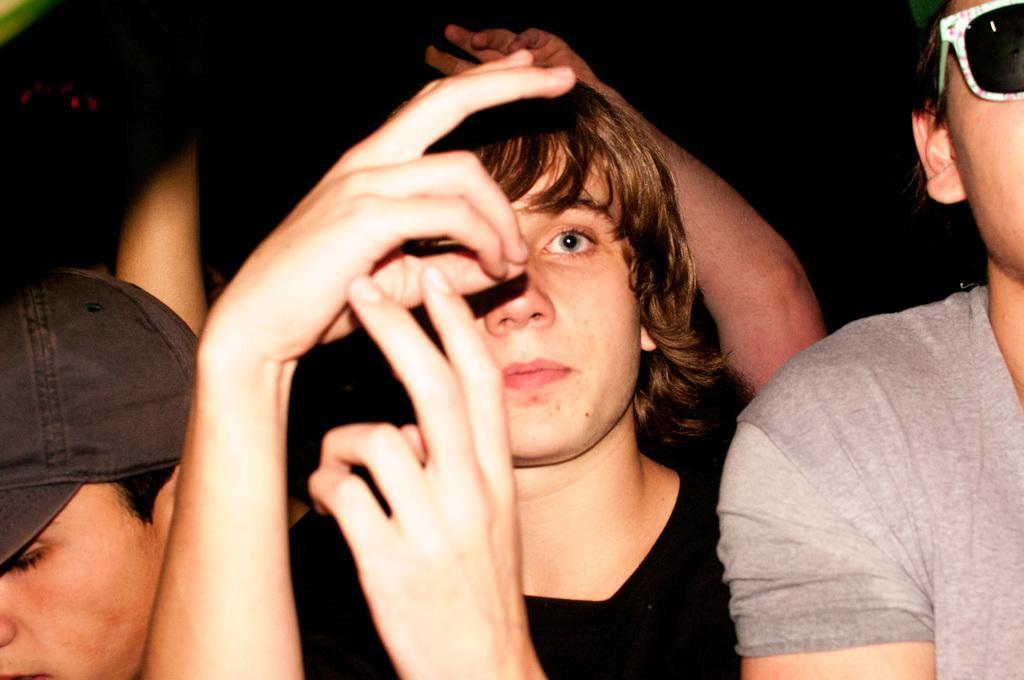How would you summarize this image in a sentence or two? In this image we can see people, on the right, there is a person wearing glasses and on the left, there is an other person wearing a cap. 